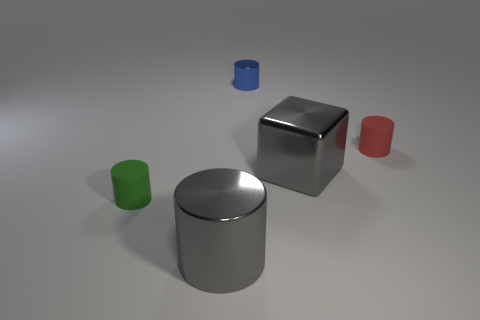Subtract 1 cylinders. How many cylinders are left? 3 Add 4 small red metallic balls. How many objects exist? 9 Subtract all cubes. How many objects are left? 4 Add 2 yellow shiny spheres. How many yellow shiny spheres exist? 2 Subtract 0 red cubes. How many objects are left? 5 Subtract all yellow metal cylinders. Subtract all green objects. How many objects are left? 4 Add 2 tiny shiny objects. How many tiny shiny objects are left? 3 